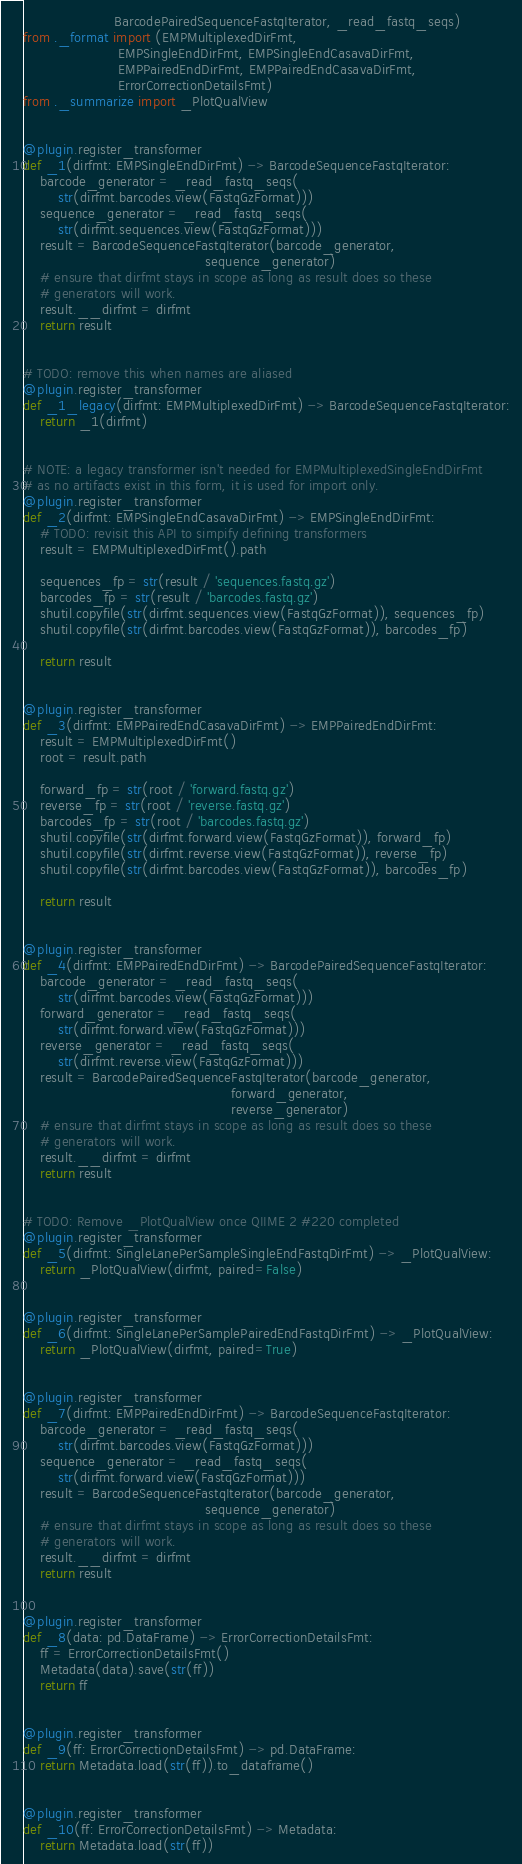Convert code to text. <code><loc_0><loc_0><loc_500><loc_500><_Python_>                     BarcodePairedSequenceFastqIterator, _read_fastq_seqs)
from ._format import (EMPMultiplexedDirFmt,
                      EMPSingleEndDirFmt, EMPSingleEndCasavaDirFmt,
                      EMPPairedEndDirFmt, EMPPairedEndCasavaDirFmt,
                      ErrorCorrectionDetailsFmt)
from ._summarize import _PlotQualView


@plugin.register_transformer
def _1(dirfmt: EMPSingleEndDirFmt) -> BarcodeSequenceFastqIterator:
    barcode_generator = _read_fastq_seqs(
        str(dirfmt.barcodes.view(FastqGzFormat)))
    sequence_generator = _read_fastq_seqs(
        str(dirfmt.sequences.view(FastqGzFormat)))
    result = BarcodeSequenceFastqIterator(barcode_generator,
                                          sequence_generator)
    # ensure that dirfmt stays in scope as long as result does so these
    # generators will work.
    result.__dirfmt = dirfmt
    return result


# TODO: remove this when names are aliased
@plugin.register_transformer
def _1_legacy(dirfmt: EMPMultiplexedDirFmt) -> BarcodeSequenceFastqIterator:
    return _1(dirfmt)


# NOTE: a legacy transformer isn't needed for EMPMultiplexedSingleEndDirFmt
# as no artifacts exist in this form, it is used for import only.
@plugin.register_transformer
def _2(dirfmt: EMPSingleEndCasavaDirFmt) -> EMPSingleEndDirFmt:
    # TODO: revisit this API to simpify defining transformers
    result = EMPMultiplexedDirFmt().path

    sequences_fp = str(result / 'sequences.fastq.gz')
    barcodes_fp = str(result / 'barcodes.fastq.gz')
    shutil.copyfile(str(dirfmt.sequences.view(FastqGzFormat)), sequences_fp)
    shutil.copyfile(str(dirfmt.barcodes.view(FastqGzFormat)), barcodes_fp)

    return result


@plugin.register_transformer
def _3(dirfmt: EMPPairedEndCasavaDirFmt) -> EMPPairedEndDirFmt:
    result = EMPMultiplexedDirFmt()
    root = result.path

    forward_fp = str(root / 'forward.fastq.gz')
    reverse_fp = str(root / 'reverse.fastq.gz')
    barcodes_fp = str(root / 'barcodes.fastq.gz')
    shutil.copyfile(str(dirfmt.forward.view(FastqGzFormat)), forward_fp)
    shutil.copyfile(str(dirfmt.reverse.view(FastqGzFormat)), reverse_fp)
    shutil.copyfile(str(dirfmt.barcodes.view(FastqGzFormat)), barcodes_fp)

    return result


@plugin.register_transformer
def _4(dirfmt: EMPPairedEndDirFmt) -> BarcodePairedSequenceFastqIterator:
    barcode_generator = _read_fastq_seqs(
        str(dirfmt.barcodes.view(FastqGzFormat)))
    forward_generator = _read_fastq_seqs(
        str(dirfmt.forward.view(FastqGzFormat)))
    reverse_generator = _read_fastq_seqs(
        str(dirfmt.reverse.view(FastqGzFormat)))
    result = BarcodePairedSequenceFastqIterator(barcode_generator,
                                                forward_generator,
                                                reverse_generator)
    # ensure that dirfmt stays in scope as long as result does so these
    # generators will work.
    result.__dirfmt = dirfmt
    return result


# TODO: Remove _PlotQualView once QIIME 2 #220 completed
@plugin.register_transformer
def _5(dirfmt: SingleLanePerSampleSingleEndFastqDirFmt) -> _PlotQualView:
    return _PlotQualView(dirfmt, paired=False)


@plugin.register_transformer
def _6(dirfmt: SingleLanePerSamplePairedEndFastqDirFmt) -> _PlotQualView:
    return _PlotQualView(dirfmt, paired=True)


@plugin.register_transformer
def _7(dirfmt: EMPPairedEndDirFmt) -> BarcodeSequenceFastqIterator:
    barcode_generator = _read_fastq_seqs(
        str(dirfmt.barcodes.view(FastqGzFormat)))
    sequence_generator = _read_fastq_seqs(
        str(dirfmt.forward.view(FastqGzFormat)))
    result = BarcodeSequenceFastqIterator(barcode_generator,
                                          sequence_generator)
    # ensure that dirfmt stays in scope as long as result does so these
    # generators will work.
    result.__dirfmt = dirfmt
    return result


@plugin.register_transformer
def _8(data: pd.DataFrame) -> ErrorCorrectionDetailsFmt:
    ff = ErrorCorrectionDetailsFmt()
    Metadata(data).save(str(ff))
    return ff


@plugin.register_transformer
def _9(ff: ErrorCorrectionDetailsFmt) -> pd.DataFrame:
    return Metadata.load(str(ff)).to_dataframe()


@plugin.register_transformer
def _10(ff: ErrorCorrectionDetailsFmt) -> Metadata:
    return Metadata.load(str(ff))
</code> 